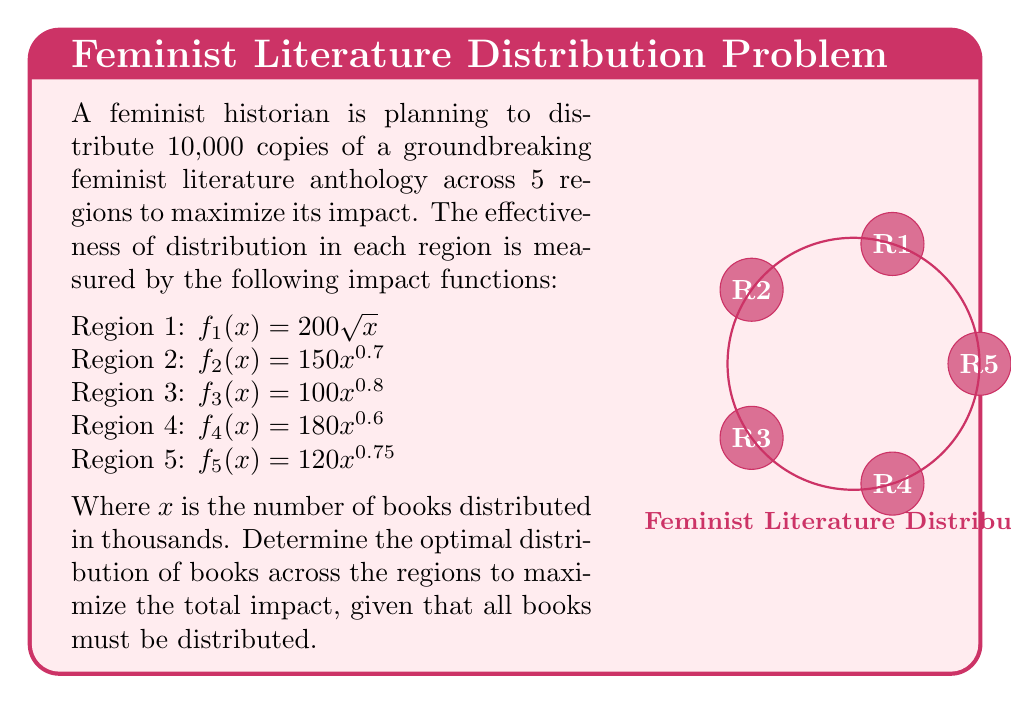Could you help me with this problem? To solve this problem, we'll use the method of Lagrange multipliers:

1) Let $x_i$ be the number of books (in thousands) distributed to region $i$. Our objective function is:

   $F = 200\sqrt{x_1} + 150x_2^{0.7} + 100x_3^{0.8} + 180x_4^{0.6} + 120x_5^{0.75}$

2) The constraint is:

   $g = x_1 + x_2 + x_3 + x_4 + x_5 - 10 = 0$

3) Form the Lagrangian:

   $L = F + \lambda g$

4) Take partial derivatives and set them equal to zero:

   $\frac{\partial L}{\partial x_1} = \frac{100}{\sqrt{x_1}} + \lambda = 0$
   $\frac{\partial L}{\partial x_2} = 105x_2^{-0.3} + \lambda = 0$
   $\frac{\partial L}{\partial x_3} = 80x_3^{-0.2} + \lambda = 0$
   $\frac{\partial L}{\partial x_4} = 108x_4^{-0.4} + \lambda = 0$
   $\frac{\partial L}{\partial x_5} = 90x_5^{-0.25} + \lambda = 0$

5) From these equations, we can derive:

   $x_1 = (\frac{100}{\lambda})^2$
   $x_2 = (\frac{105}{\lambda})^{10/3}$
   $x_3 = (\frac{80}{\lambda})^5$
   $x_4 = (\frac{108}{\lambda})^{5/2}$
   $x_5 = (\frac{90}{\lambda})^4$

6) Substitute these into the constraint equation:

   $(\frac{100}{\lambda})^2 + (\frac{105}{\lambda})^{10/3} + (\frac{80}{\lambda})^5 + (\frac{108}{\lambda})^{5/2} + (\frac{90}{\lambda})^4 = 10$

7) Solve this equation numerically to find $\lambda \approx 44.72$

8) Substitute this value back into the equations from step 5 to find the optimal distribution:

   $x_1 \approx 5.00$, $x_2 \approx 1.37$, $x_3 \approx 1.21$, $x_4 \approx 1.46$, $x_5 \approx 0.96$

9) Convert back to actual number of books:

   Region 1: 5,000 books
   Region 2: 1,370 books
   Region 3: 1,210 books
   Region 4: 1,460 books
   Region 5: 960 books
Answer: Region 1: 5000, Region 2: 1370, Region 3: 1210, Region 4: 1460, Region 5: 960 